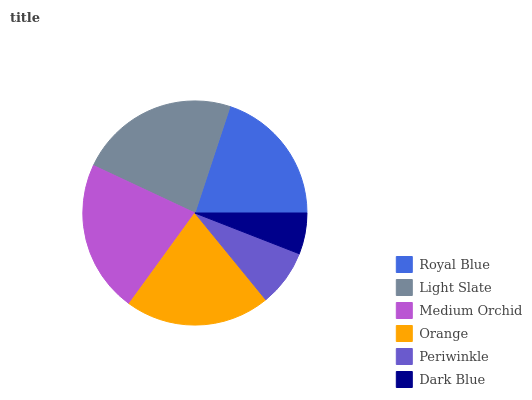Is Dark Blue the minimum?
Answer yes or no. Yes. Is Light Slate the maximum?
Answer yes or no. Yes. Is Medium Orchid the minimum?
Answer yes or no. No. Is Medium Orchid the maximum?
Answer yes or no. No. Is Light Slate greater than Medium Orchid?
Answer yes or no. Yes. Is Medium Orchid less than Light Slate?
Answer yes or no. Yes. Is Medium Orchid greater than Light Slate?
Answer yes or no. No. Is Light Slate less than Medium Orchid?
Answer yes or no. No. Is Orange the high median?
Answer yes or no. Yes. Is Royal Blue the low median?
Answer yes or no. Yes. Is Dark Blue the high median?
Answer yes or no. No. Is Light Slate the low median?
Answer yes or no. No. 